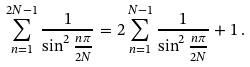<formula> <loc_0><loc_0><loc_500><loc_500>\sum ^ { 2 N - 1 } _ { n = 1 } \frac { 1 } { \sin ^ { 2 } \frac { n \pi } { 2 N } } = 2 \sum ^ { N - 1 } _ { n = 1 } \frac { 1 } { \sin ^ { 2 } \frac { n \pi } { 2 N } } + 1 \, .</formula> 